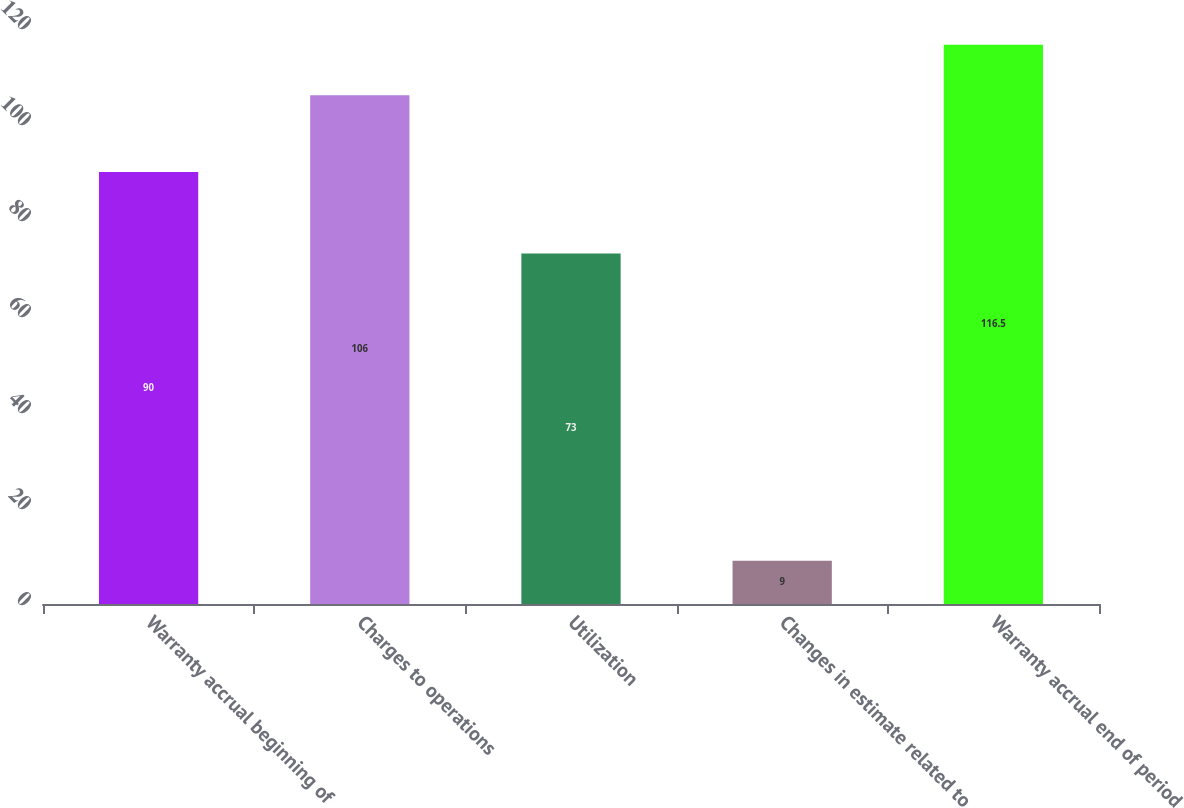<chart> <loc_0><loc_0><loc_500><loc_500><bar_chart><fcel>Warranty accrual beginning of<fcel>Charges to operations<fcel>Utilization<fcel>Changes in estimate related to<fcel>Warranty accrual end of period<nl><fcel>90<fcel>106<fcel>73<fcel>9<fcel>116.5<nl></chart> 